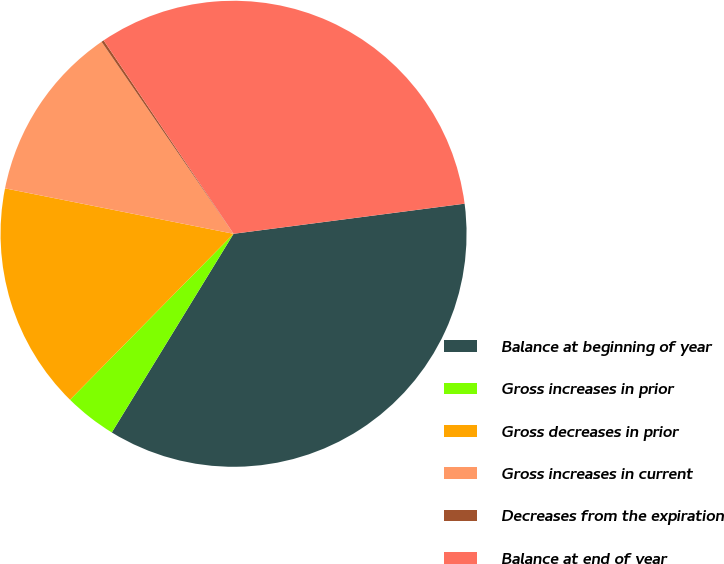Convert chart to OTSL. <chart><loc_0><loc_0><loc_500><loc_500><pie_chart><fcel>Balance at beginning of year<fcel>Gross increases in prior<fcel>Gross decreases in prior<fcel>Gross increases in current<fcel>Decreases from the expiration<fcel>Balance at end of year<nl><fcel>35.81%<fcel>3.63%<fcel>15.74%<fcel>12.29%<fcel>0.17%<fcel>32.35%<nl></chart> 